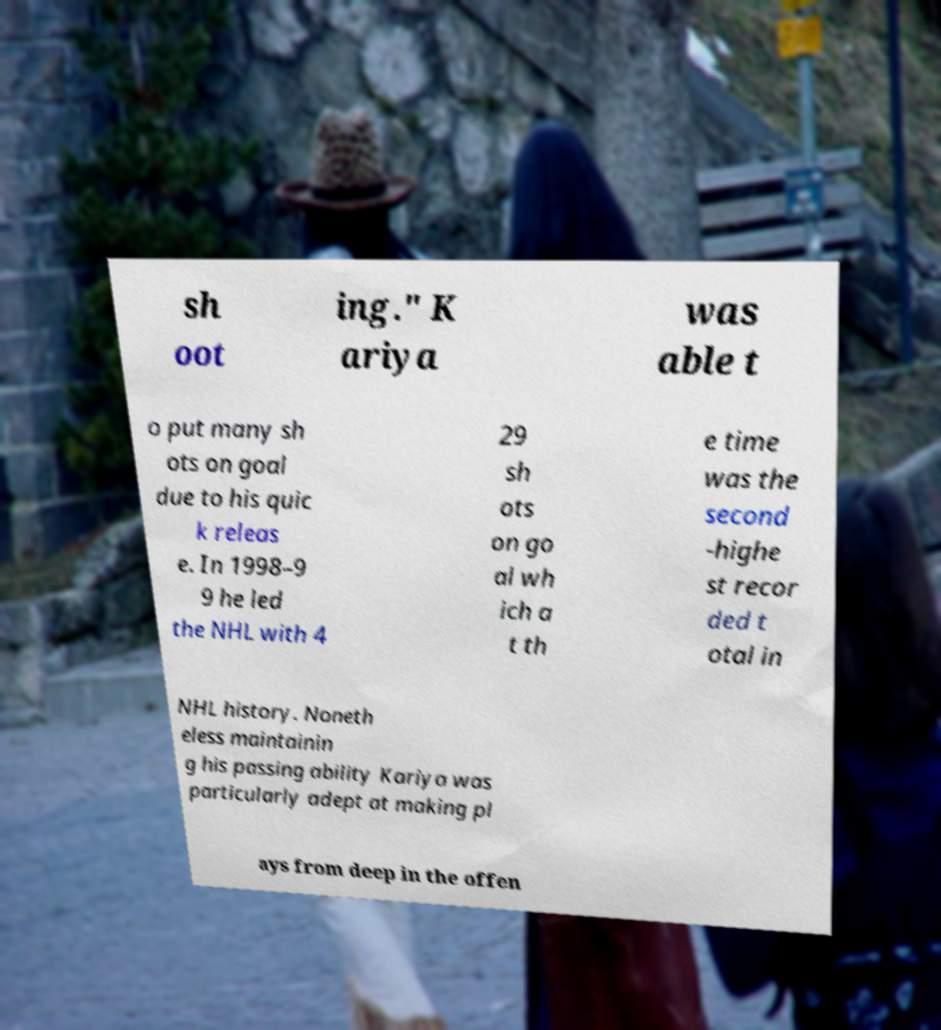Can you read and provide the text displayed in the image?This photo seems to have some interesting text. Can you extract and type it out for me? sh oot ing." K ariya was able t o put many sh ots on goal due to his quic k releas e. In 1998–9 9 he led the NHL with 4 29 sh ots on go al wh ich a t th e time was the second -highe st recor ded t otal in NHL history. Noneth eless maintainin g his passing ability Kariya was particularly adept at making pl ays from deep in the offen 